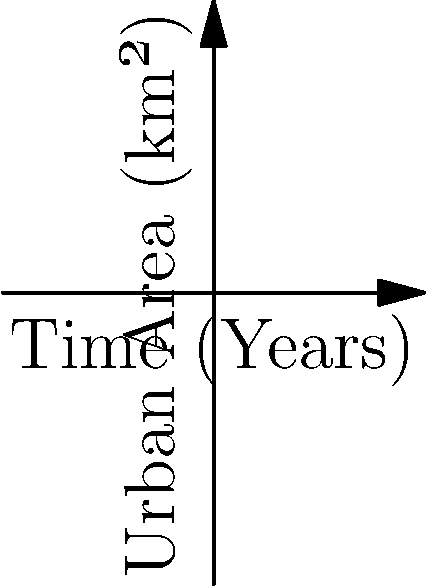The graph shows the urban growth of the San Juan metropolitan area over 40 years. If this trend continues, what will be the approximate urban area (in km²) after 50 years, and what potential environmental impacts could this level of urban sprawl have on the island's ecosystems? To answer this question, we need to follow these steps:

1. Analyze the growth pattern:
   The curve shows exponential growth, with the rate of urbanization increasing over time.

2. Extrapolate the trend:
   At 40 years, the urban area is approximately 510 km².
   The growth rate between 30 and 40 years is (510 - 340) / 340 ≈ 50% per decade.

3. Estimate the area at 50 years:
   Assuming the 50% growth rate continues for another decade:
   510 km² * 1.5 ≈ 765 km²

4. Consider potential environmental impacts:
   a) Habitat loss: Expansion into natural areas, affecting biodiversity.
   b) Increased impervious surfaces: Leading to more runoff and potential flooding.
   c) Air quality degradation: Due to increased traffic and energy consumption.
   d) Water resource strain: Higher demand on limited freshwater supplies.
   e) Coastal ecosystem stress: If expansion occurs near shorelines.
   f) Urban heat island effect: Raising local temperatures and energy needs.
   g) Fragmentation of ecosystems: Disrupting wildlife corridors and migration patterns.

5. Contextualize for Puerto Rico:
   As an island with limited land area, this level of urban sprawl could significantly impact the overall ecological balance and natural resource availability.
Answer: 765 km²; habitat loss, increased runoff, air pollution, water scarcity, coastal degradation, urban heat island effect, ecosystem fragmentation. 